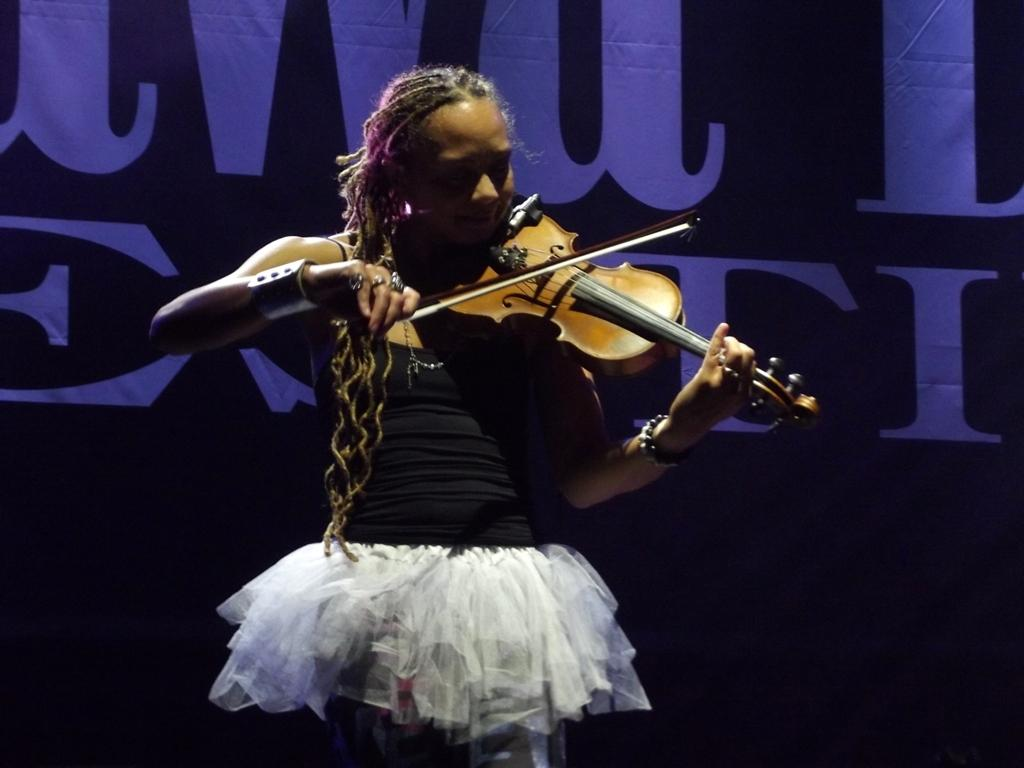Who is the main subject in the image? There is a woman in the image. What is the woman wearing? The woman is wearing a black and white frock. What is the woman doing in the image? The woman is playing a violin. What can be seen in the background of the image? There is a banner in the background of the image. What type of wall can be seen behind the woman in the image? There is no wall visible in the image; it only shows the woman playing the violin and a banner in the background. What is the woman using to carry water in the image? There is no pail or any object used for carrying water present in the image. 